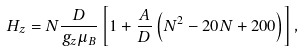Convert formula to latex. <formula><loc_0><loc_0><loc_500><loc_500>H _ { z } = N \frac { D } { g _ { z } \mu _ { B } } \left [ 1 + \frac { A } { D } \left ( N ^ { 2 } - 2 0 N + 2 0 0 \right ) \right ] ,</formula> 